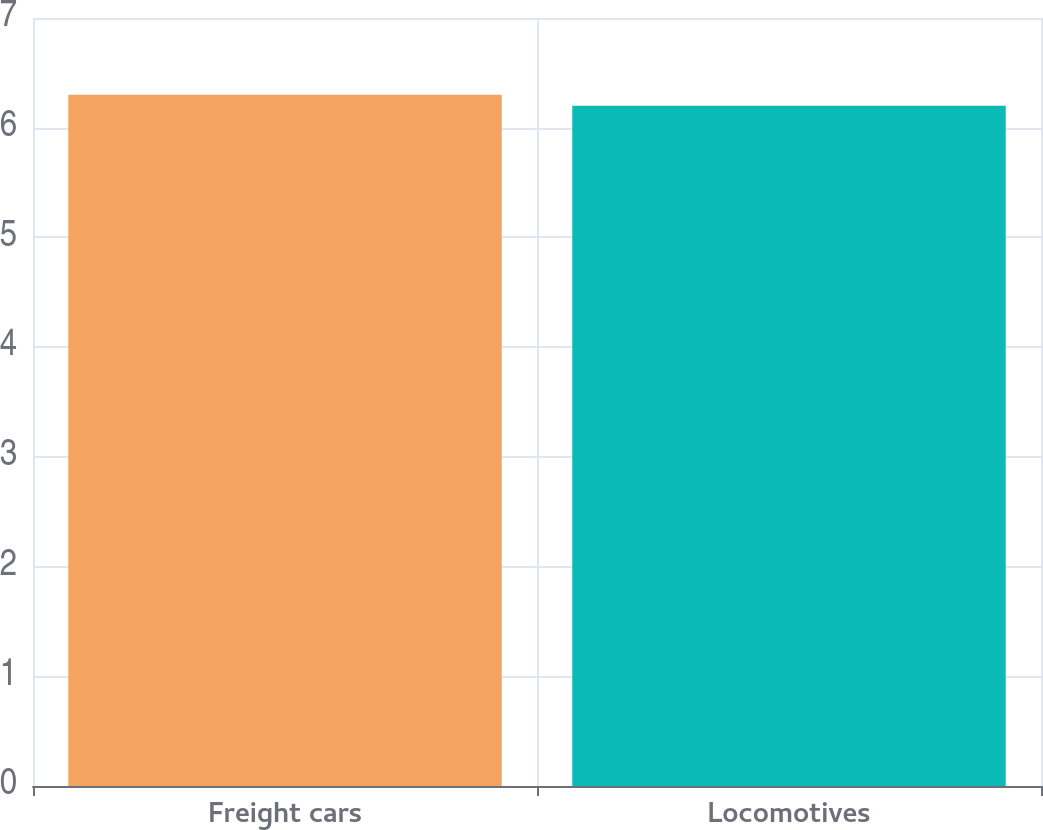Convert chart to OTSL. <chart><loc_0><loc_0><loc_500><loc_500><bar_chart><fcel>Freight cars<fcel>Locomotives<nl><fcel>6.3<fcel>6.2<nl></chart> 